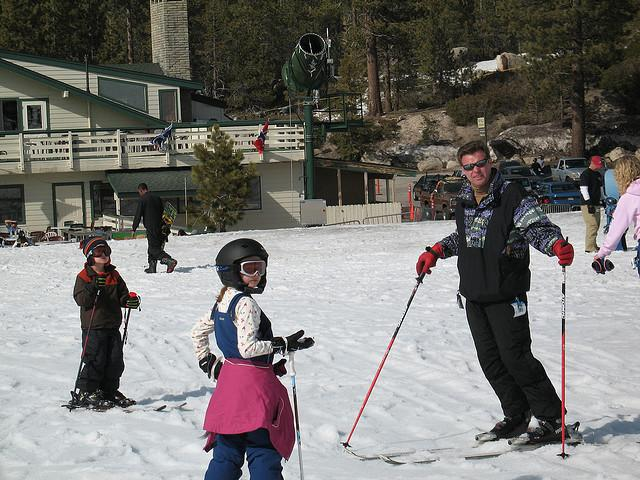What is the man in black behind the child walking away with? snowboard 